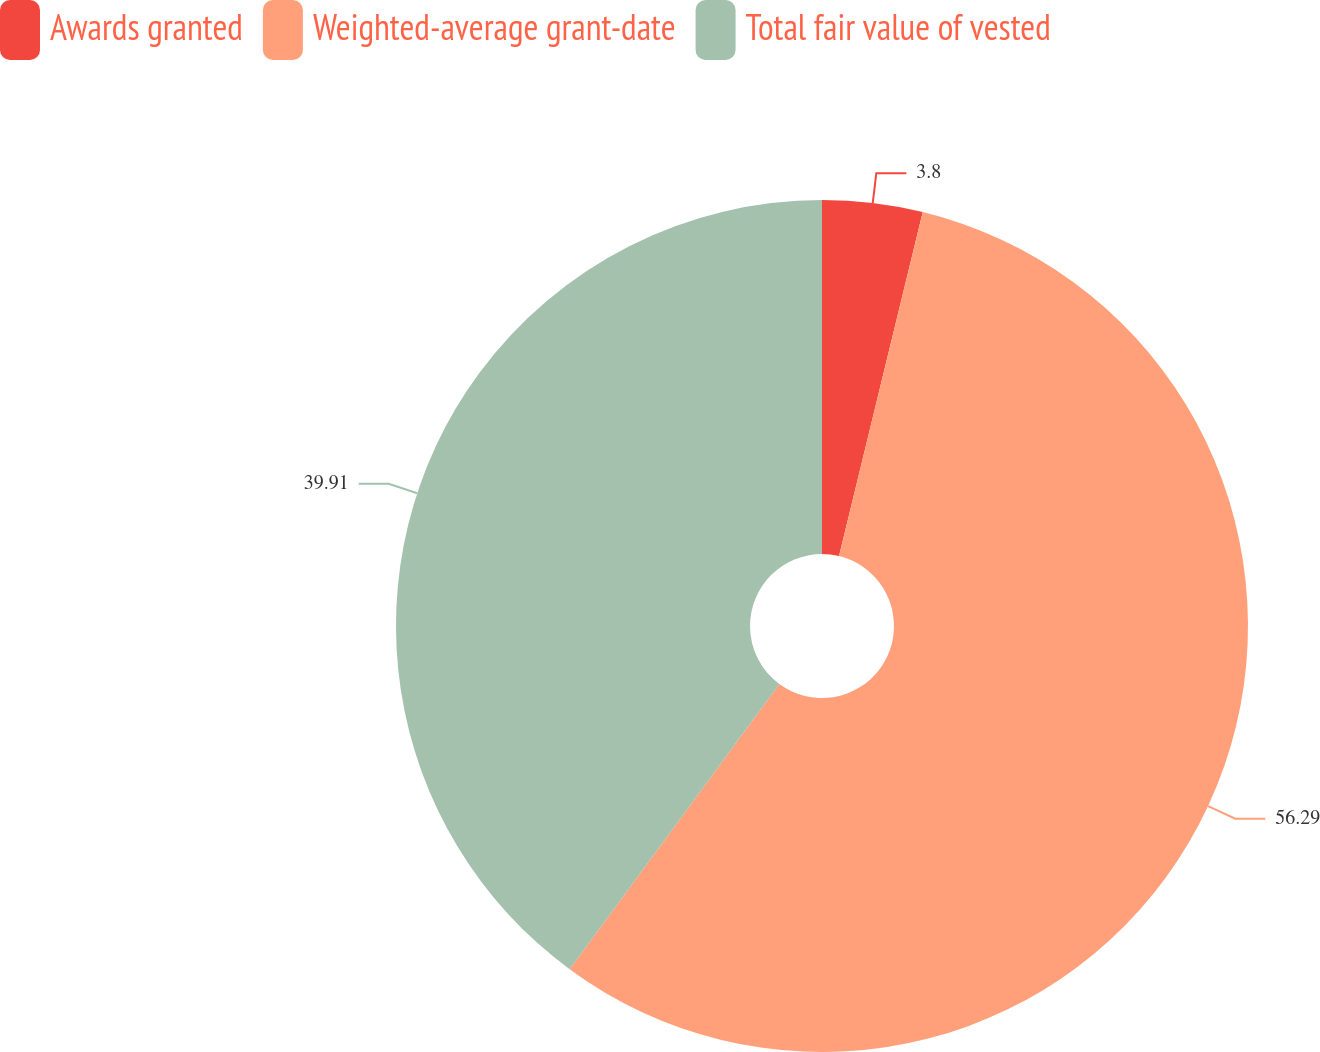Convert chart to OTSL. <chart><loc_0><loc_0><loc_500><loc_500><pie_chart><fcel>Awards granted<fcel>Weighted-average grant-date<fcel>Total fair value of vested<nl><fcel>3.8%<fcel>56.29%<fcel>39.91%<nl></chart> 